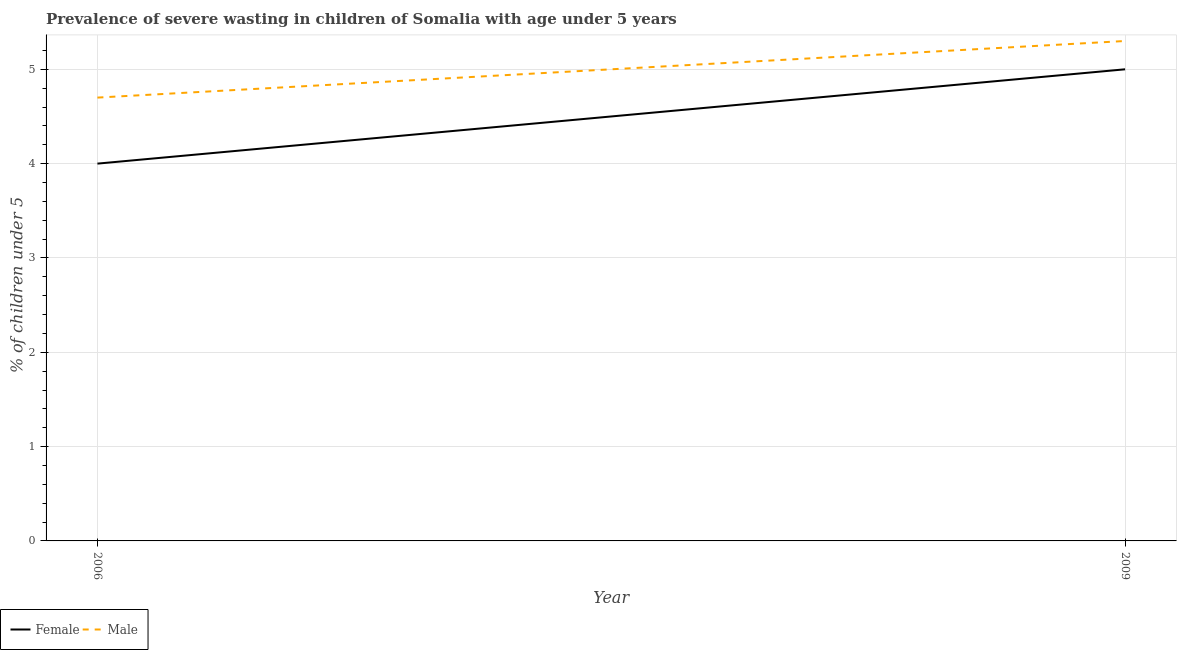What is the percentage of undernourished male children in 2006?
Your answer should be very brief. 4.7. Across all years, what is the maximum percentage of undernourished female children?
Your response must be concise. 5. Across all years, what is the minimum percentage of undernourished male children?
Offer a terse response. 4.7. In which year was the percentage of undernourished female children maximum?
Your response must be concise. 2009. What is the total percentage of undernourished female children in the graph?
Provide a succinct answer. 9. What is the difference between the percentage of undernourished male children in 2006 and that in 2009?
Keep it short and to the point. -0.6. What is the difference between the percentage of undernourished male children in 2009 and the percentage of undernourished female children in 2006?
Offer a terse response. 1.3. In the year 2009, what is the difference between the percentage of undernourished male children and percentage of undernourished female children?
Provide a short and direct response. 0.3. In how many years, is the percentage of undernourished female children greater than 4.4 %?
Your response must be concise. 1. What is the ratio of the percentage of undernourished female children in 2006 to that in 2009?
Offer a terse response. 0.8. Does the percentage of undernourished female children monotonically increase over the years?
Provide a succinct answer. Yes. Is the percentage of undernourished male children strictly greater than the percentage of undernourished female children over the years?
Your answer should be very brief. Yes. How many lines are there?
Provide a short and direct response. 2. Does the graph contain any zero values?
Provide a succinct answer. No. How are the legend labels stacked?
Offer a very short reply. Horizontal. What is the title of the graph?
Provide a succinct answer. Prevalence of severe wasting in children of Somalia with age under 5 years. What is the label or title of the X-axis?
Make the answer very short. Year. What is the label or title of the Y-axis?
Your response must be concise.  % of children under 5. What is the  % of children under 5 in Female in 2006?
Ensure brevity in your answer.  4. What is the  % of children under 5 in Male in 2006?
Provide a short and direct response. 4.7. What is the  % of children under 5 in Male in 2009?
Provide a short and direct response. 5.3. Across all years, what is the maximum  % of children under 5 of Male?
Your answer should be very brief. 5.3. Across all years, what is the minimum  % of children under 5 of Male?
Provide a short and direct response. 4.7. What is the total  % of children under 5 in Male in the graph?
Provide a succinct answer. 10. What is the average  % of children under 5 of Male per year?
Give a very brief answer. 5. In the year 2009, what is the difference between the  % of children under 5 of Female and  % of children under 5 of Male?
Make the answer very short. -0.3. What is the ratio of the  % of children under 5 in Female in 2006 to that in 2009?
Offer a terse response. 0.8. What is the ratio of the  % of children under 5 in Male in 2006 to that in 2009?
Your response must be concise. 0.89. What is the difference between the highest and the second highest  % of children under 5 of Male?
Provide a succinct answer. 0.6. 